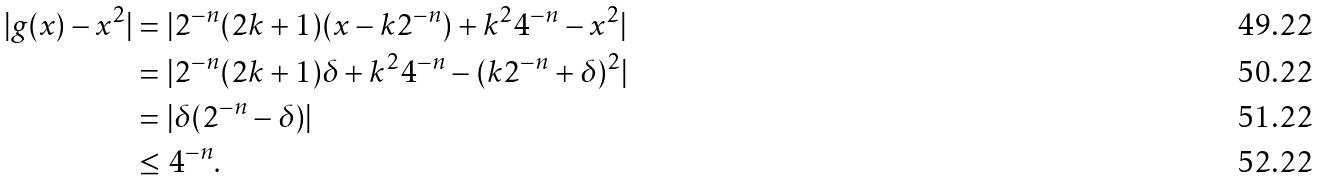Convert formula to latex. <formula><loc_0><loc_0><loc_500><loc_500>| g ( x ) - x ^ { 2 } | & = | 2 ^ { - n } ( 2 k + 1 ) ( x - k 2 ^ { - n } ) + k ^ { 2 } 4 ^ { - n } - x ^ { 2 } | \\ & = | 2 ^ { - n } ( 2 k + 1 ) \delta + k ^ { 2 } 4 ^ { - n } - ( k 2 ^ { - n } + \delta ) ^ { 2 } | \\ & = | \delta ( 2 ^ { - n } - \delta ) | \\ & \leq 4 ^ { - n } .</formula> 